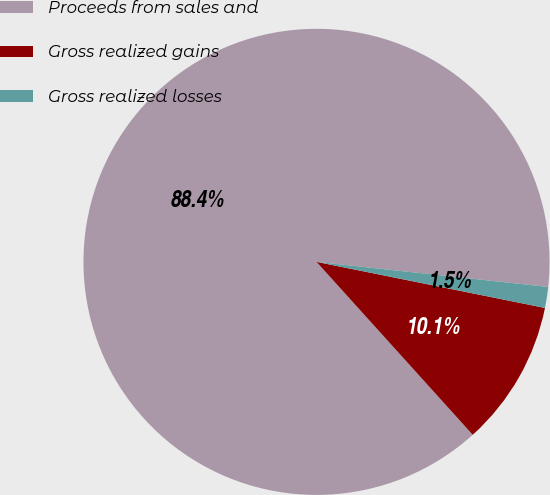Convert chart. <chart><loc_0><loc_0><loc_500><loc_500><pie_chart><fcel>Proceeds from sales and<fcel>Gross realized gains<fcel>Gross realized losses<nl><fcel>88.41%<fcel>10.14%<fcel>1.45%<nl></chart> 